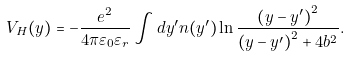Convert formula to latex. <formula><loc_0><loc_0><loc_500><loc_500>V _ { H } ( y ) = - \frac { e ^ { 2 } } { 4 \pi \varepsilon _ { 0 } \varepsilon _ { r } } \int d y ^ { \prime } n ( y ^ { \prime } ) \ln \frac { \left ( y - y ^ { \prime } \right ) ^ { 2 } } { \left ( y - y ^ { \prime } \right ) ^ { 2 } + 4 b ^ { 2 } } .</formula> 